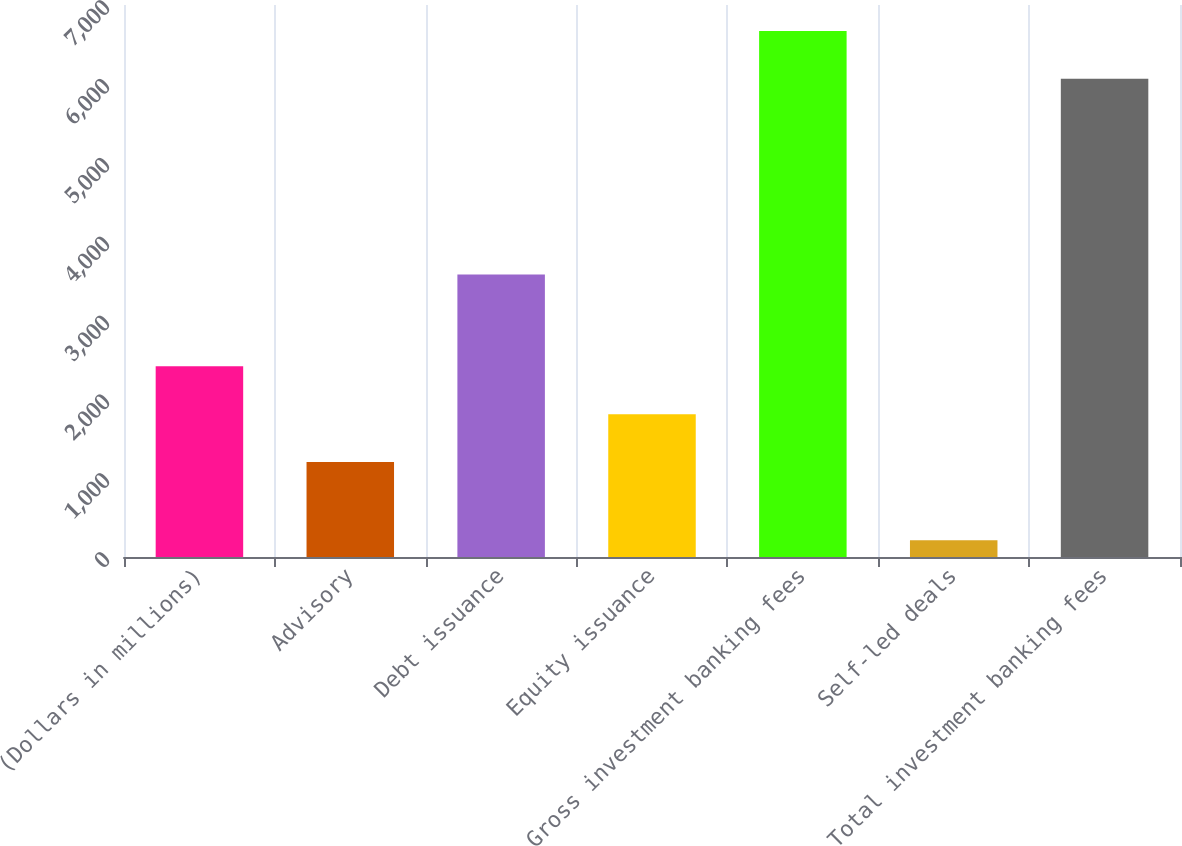Convert chart to OTSL. <chart><loc_0><loc_0><loc_500><loc_500><bar_chart><fcel>(Dollars in millions)<fcel>Advisory<fcel>Debt issuance<fcel>Equity issuance<fcel>Gross investment banking fees<fcel>Self-led deals<fcel>Total investment banking fees<nl><fcel>2418<fcel>1205<fcel>3583<fcel>1811.5<fcel>6671.5<fcel>213<fcel>6065<nl></chart> 